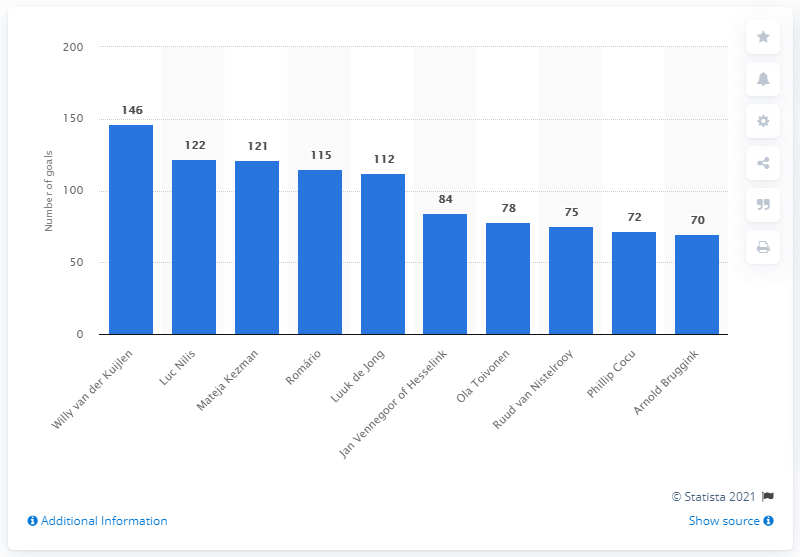Indicate a few pertinent items in this graphic. In 2019, Willy van der Kuijlen was the all-time leading goal scorer for a football club. Luc Nilis, a talented soccer player who played for PSV Eindhoven, scored a remarkable 122 goals in 203 appearances for the team. 